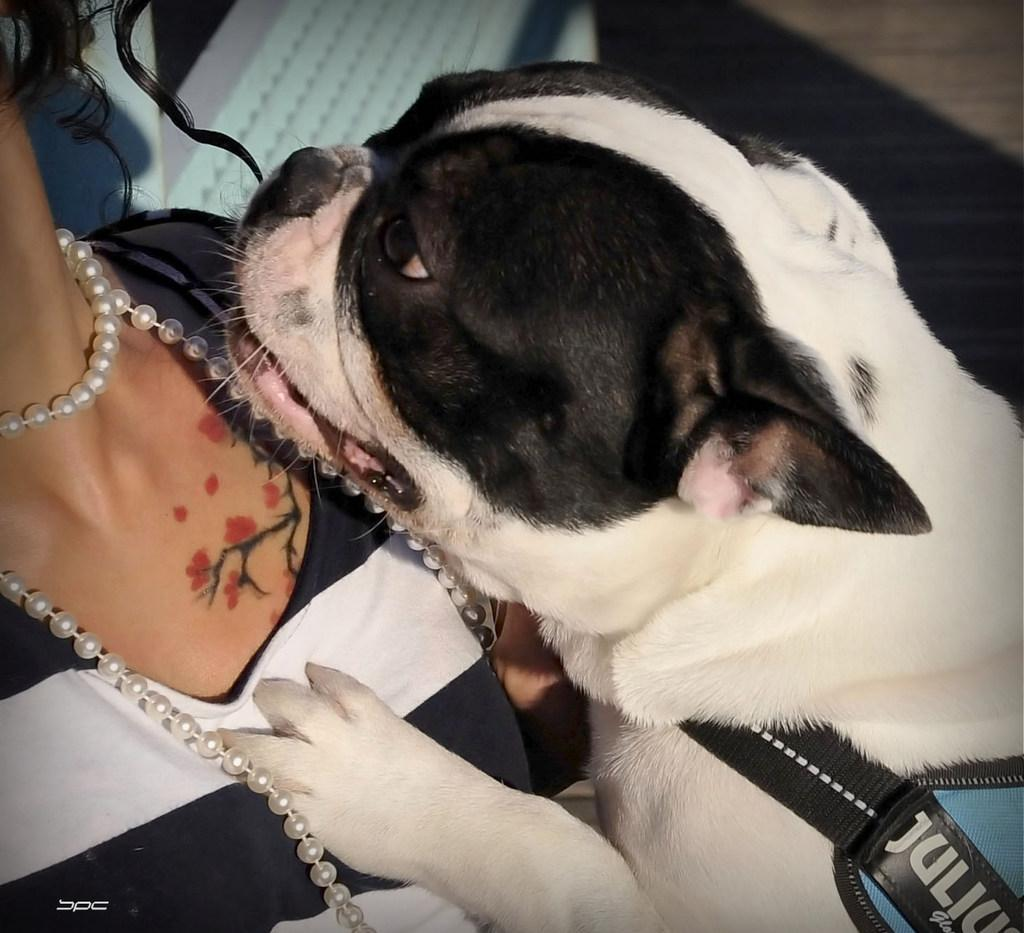What type of animal is present in the image? There is a dog in the image. What is the dog's focus in the image? The dog is staring at a woman's body. What type of border is visible around the woman's body in the image? There is no border visible around the woman's body in the image. Can you see a receipt in the image? There is no receipt present in the image. 